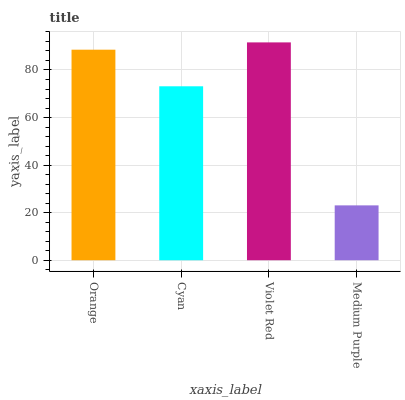Is Cyan the minimum?
Answer yes or no. No. Is Cyan the maximum?
Answer yes or no. No. Is Orange greater than Cyan?
Answer yes or no. Yes. Is Cyan less than Orange?
Answer yes or no. Yes. Is Cyan greater than Orange?
Answer yes or no. No. Is Orange less than Cyan?
Answer yes or no. No. Is Orange the high median?
Answer yes or no. Yes. Is Cyan the low median?
Answer yes or no. Yes. Is Medium Purple the high median?
Answer yes or no. No. Is Violet Red the low median?
Answer yes or no. No. 